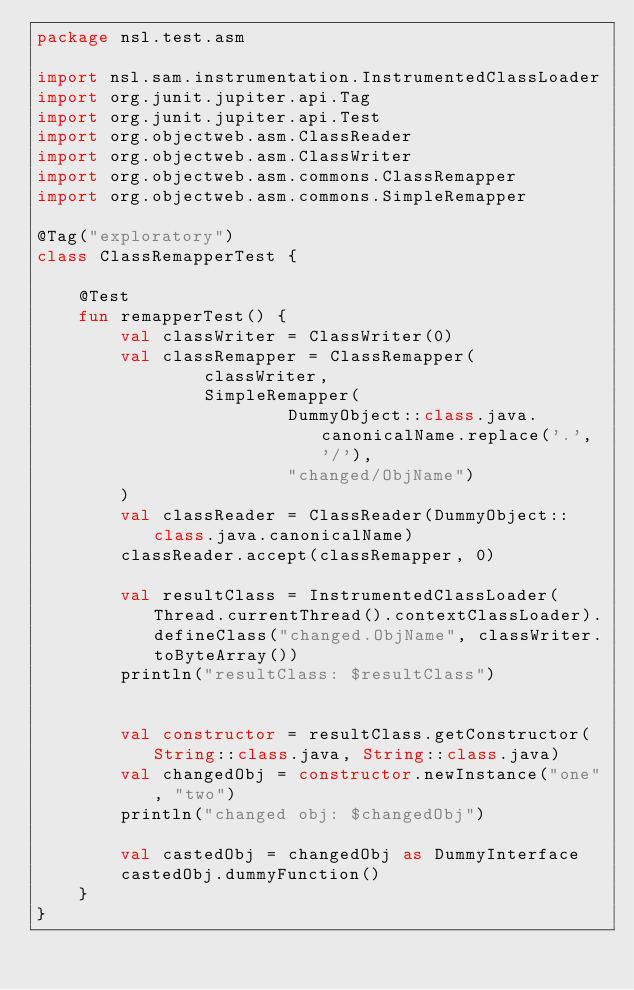Convert code to text. <code><loc_0><loc_0><loc_500><loc_500><_Kotlin_>package nsl.test.asm

import nsl.sam.instrumentation.InstrumentedClassLoader
import org.junit.jupiter.api.Tag
import org.junit.jupiter.api.Test
import org.objectweb.asm.ClassReader
import org.objectweb.asm.ClassWriter
import org.objectweb.asm.commons.ClassRemapper
import org.objectweb.asm.commons.SimpleRemapper

@Tag("exploratory")
class ClassRemapperTest {

    @Test
    fun remapperTest() {
        val classWriter = ClassWriter(0)
        val classRemapper = ClassRemapper(
                classWriter,
                SimpleRemapper(
                        DummyObject::class.java.canonicalName.replace('.', '/'),
                        "changed/ObjName")
        )
        val classReader = ClassReader(DummyObject::class.java.canonicalName)
        classReader.accept(classRemapper, 0)

        val resultClass = InstrumentedClassLoader(Thread.currentThread().contextClassLoader).defineClass("changed.ObjName", classWriter.toByteArray())
        println("resultClass: $resultClass")


        val constructor = resultClass.getConstructor(String::class.java, String::class.java)
        val changedObj = constructor.newInstance("one", "two")
        println("changed obj: $changedObj")

        val castedObj = changedObj as DummyInterface
        castedObj.dummyFunction()
    }
}</code> 